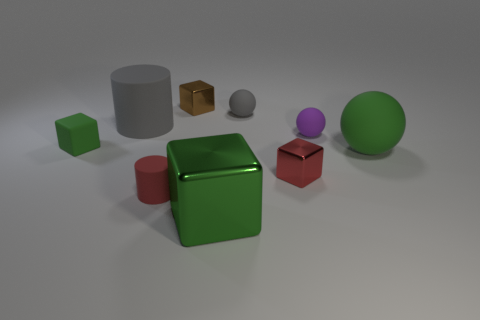Subtract all brown cylinders. Subtract all yellow balls. How many cylinders are left? 2 Add 1 small red matte objects. How many objects exist? 10 Subtract all blocks. How many objects are left? 5 Subtract all shiny cubes. Subtract all large gray cubes. How many objects are left? 6 Add 9 purple objects. How many purple objects are left? 10 Add 1 tiny purple cubes. How many tiny purple cubes exist? 1 Subtract 1 purple spheres. How many objects are left? 8 